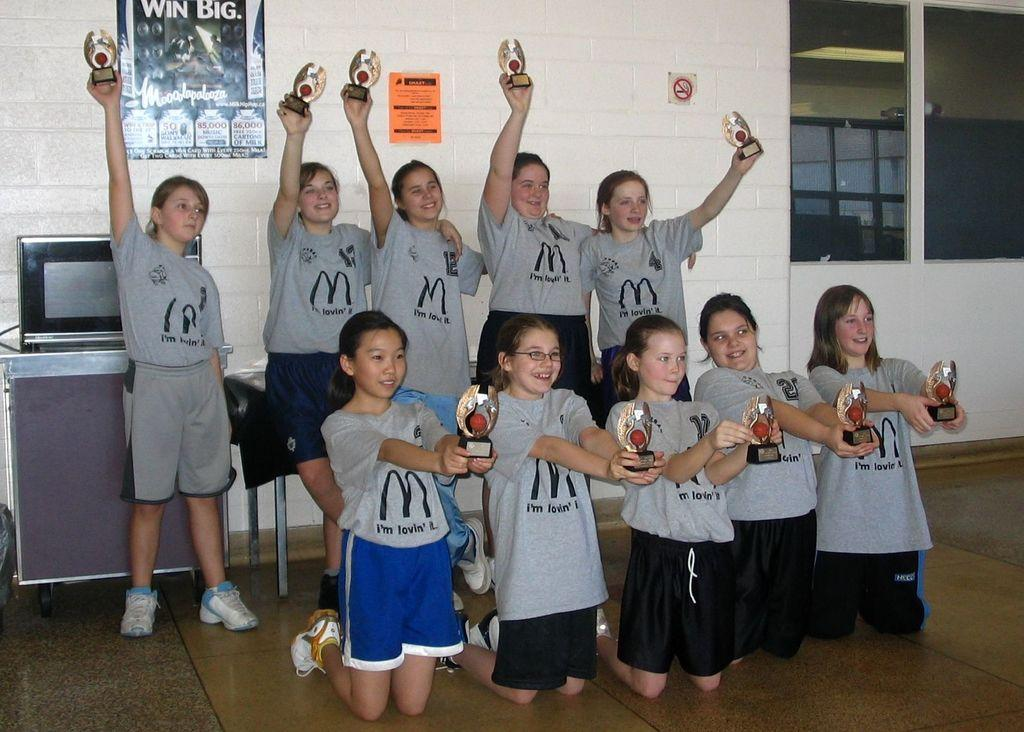Provide a one-sentence caption for the provided image. A group of girls holding trophies and wearing Mcdonald's t shirts. 